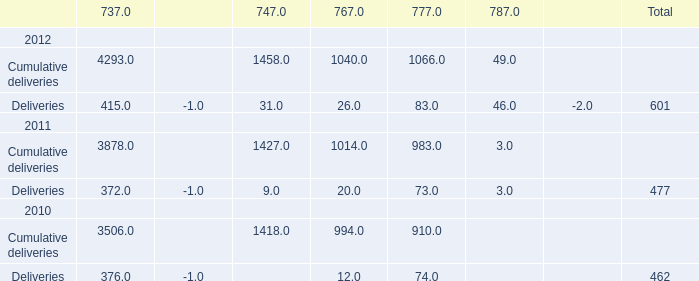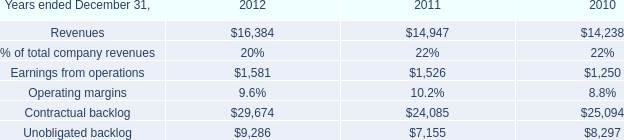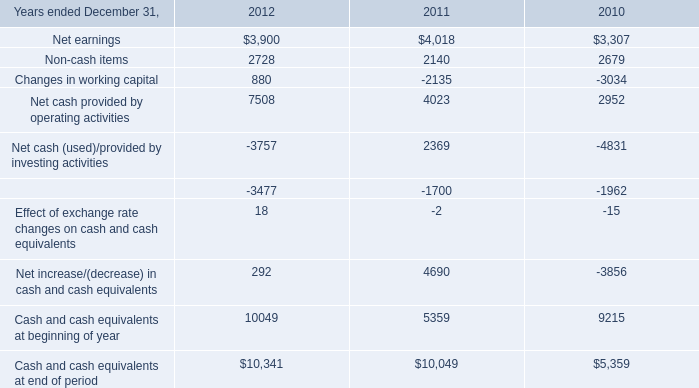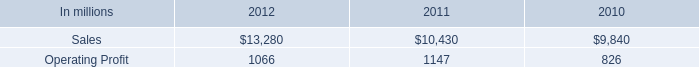What's the total amount of the Deliveries of 737 in the years where Deliveries totally is greater than 462? 
Answer: 415. 